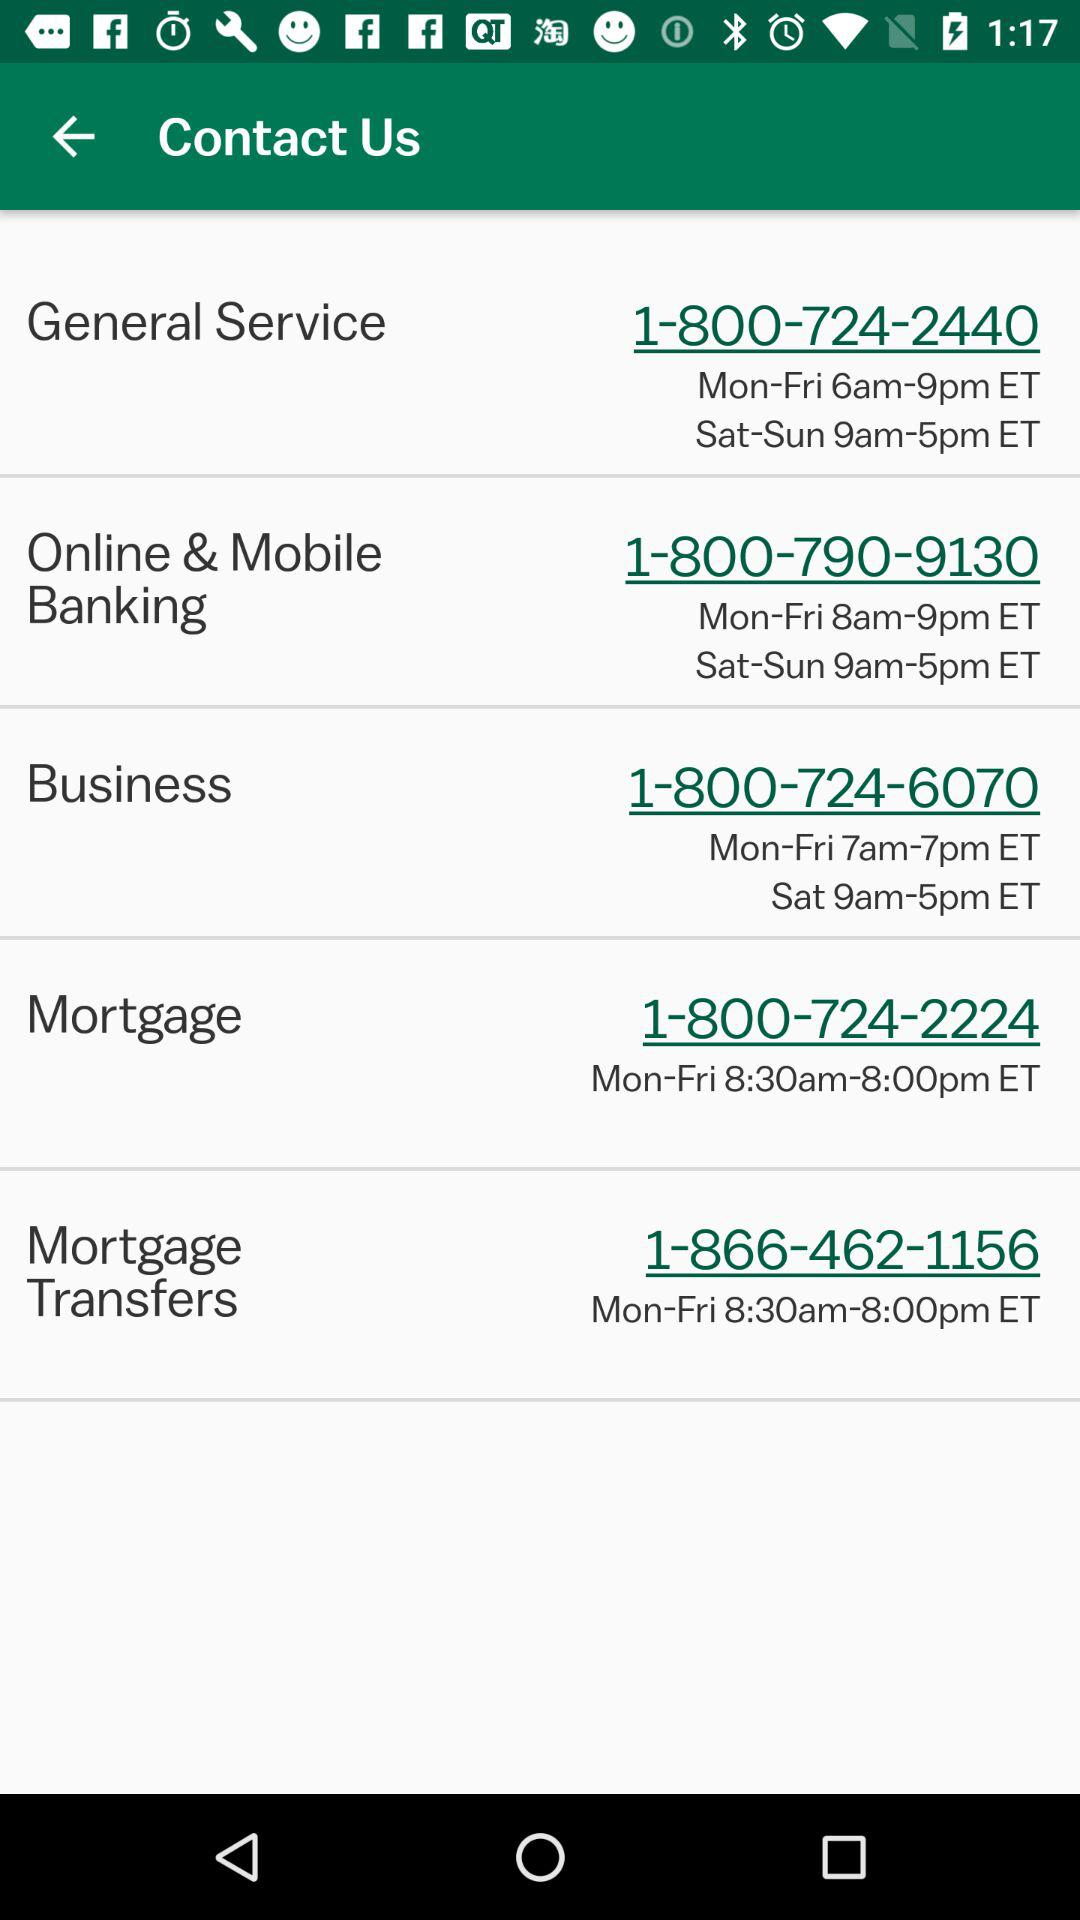How many of the phone numbers start with 1-800?
Answer the question using a single word or phrase. 4 